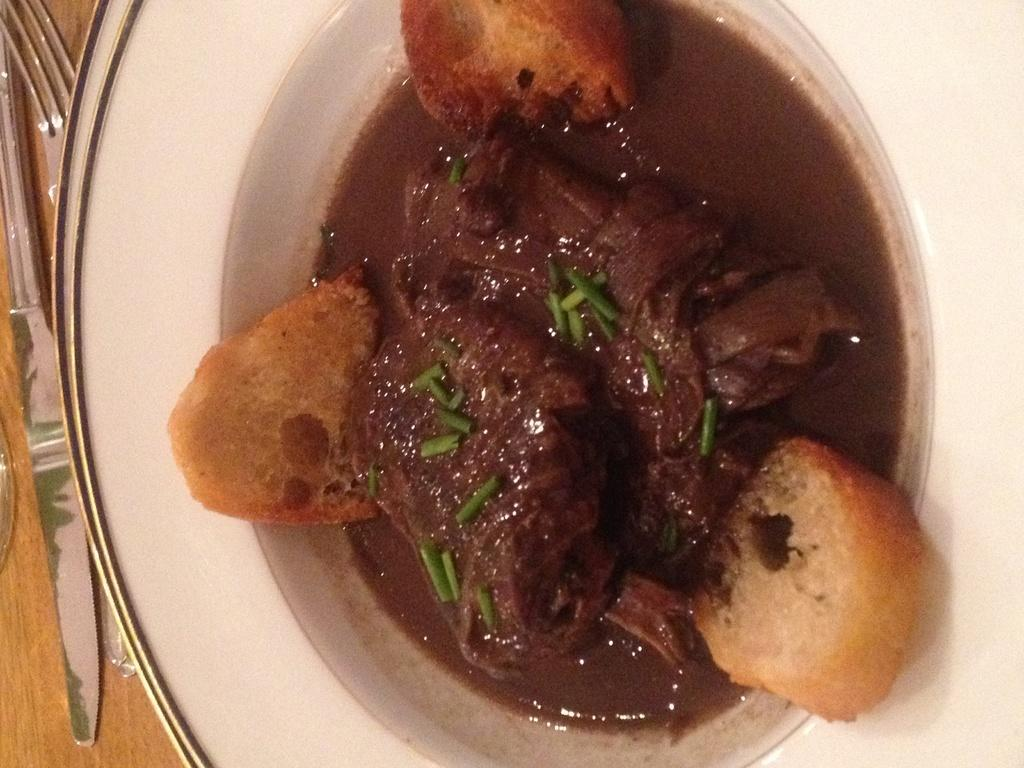What type of cooked food item is served in the plate in the image? The specific type of cooked food item is not mentioned in the facts provided. What utensil is placed beside the plate in the image? There is a fork beside the plate in the image. How many planes are flying over the cooked food item in the image? There is no mention of planes in the image, so we cannot answer that question. 